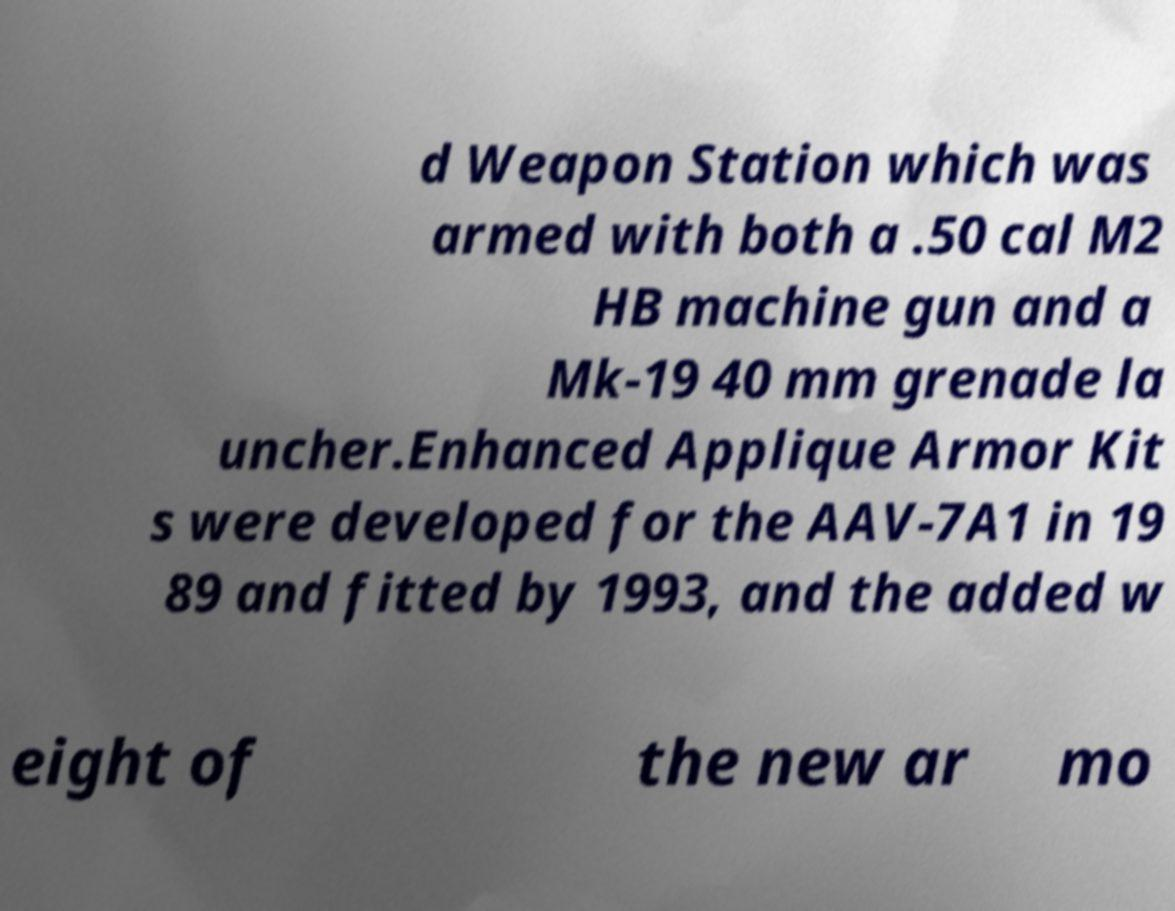There's text embedded in this image that I need extracted. Can you transcribe it verbatim? d Weapon Station which was armed with both a .50 cal M2 HB machine gun and a Mk-19 40 mm grenade la uncher.Enhanced Applique Armor Kit s were developed for the AAV-7A1 in 19 89 and fitted by 1993, and the added w eight of the new ar mo 